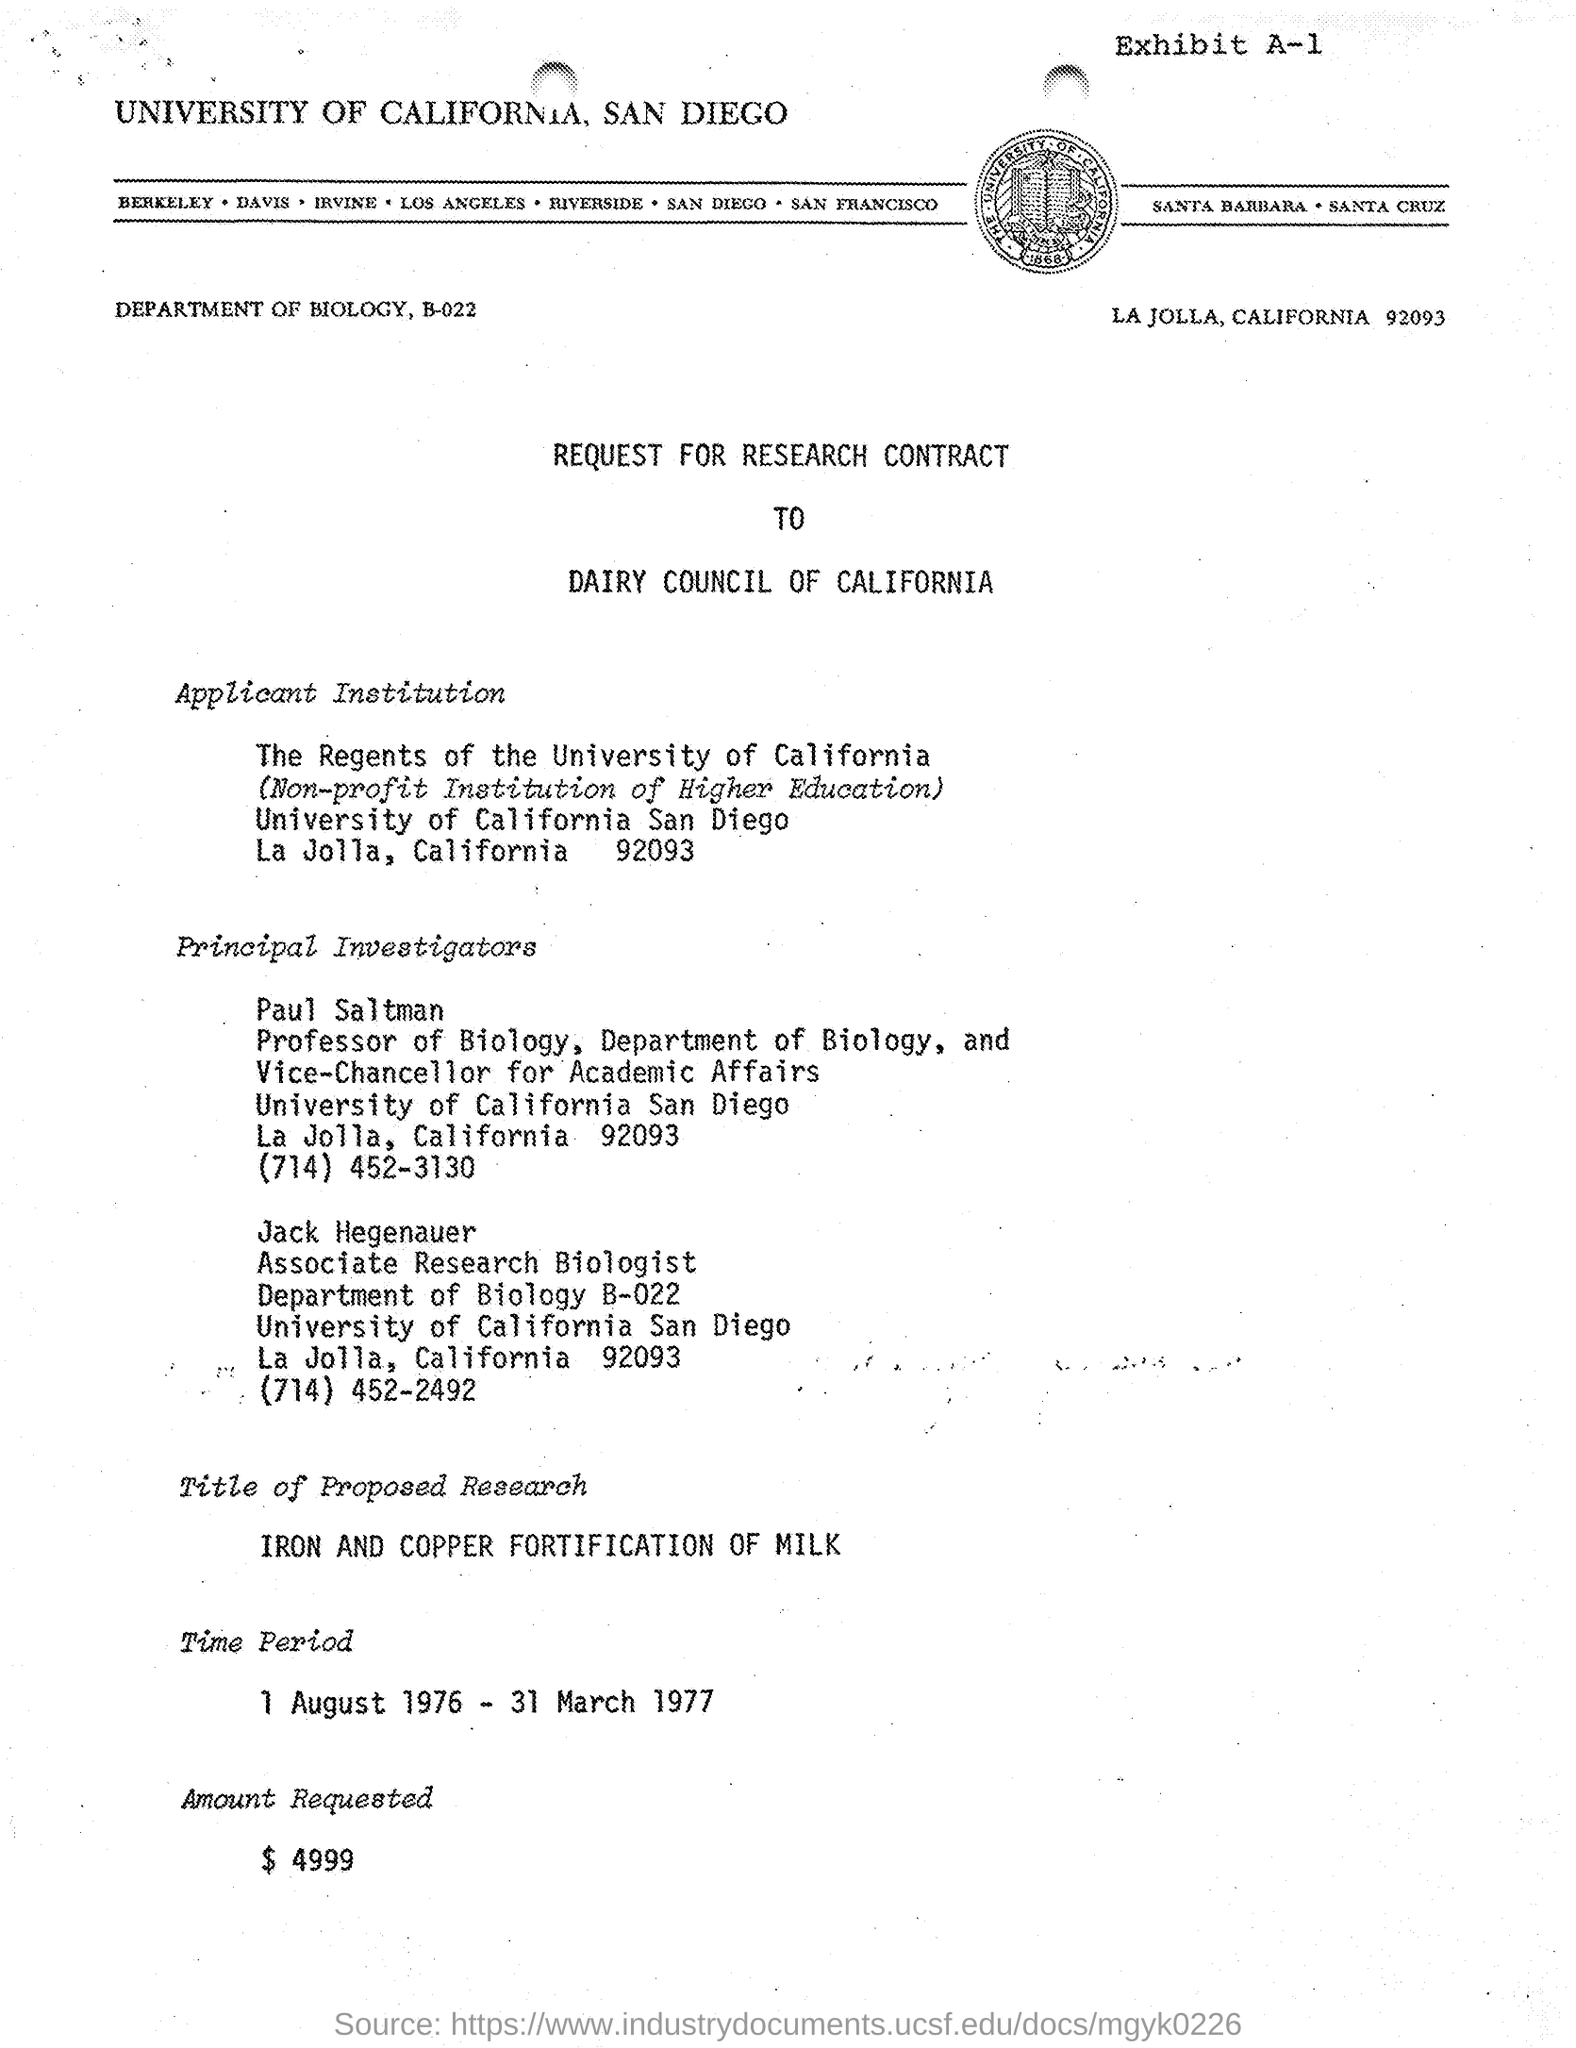Point out several critical features in this image. The Regents of the University of California is the Applicant Institution listed in the document. Paul Saltman is the Vice Chancellor for Academic Affairs at the University of California - San Diego. The Research contract's time period is from 1 August 1976 to 31 March 1977. The amount requested, as per the provided document, is $4,999. University of California, San Diego is mentioned in the header of the document. 